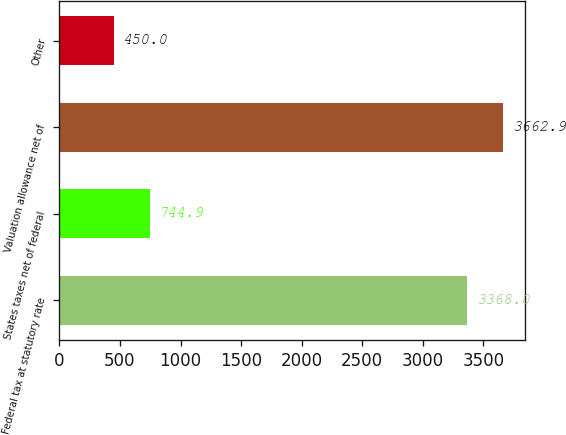Convert chart. <chart><loc_0><loc_0><loc_500><loc_500><bar_chart><fcel>Federal tax at statutory rate<fcel>States taxes net of federal<fcel>Valuation allowance net of<fcel>Other<nl><fcel>3368<fcel>744.9<fcel>3662.9<fcel>450<nl></chart> 